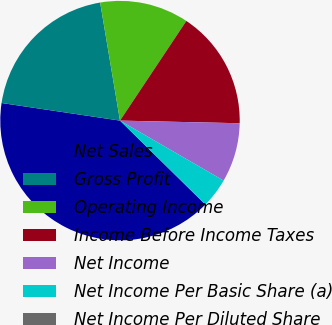Convert chart to OTSL. <chart><loc_0><loc_0><loc_500><loc_500><pie_chart><fcel>Net Sales<fcel>Gross Profit<fcel>Operating Income<fcel>Income Before Income Taxes<fcel>Net Income<fcel>Net Income Per Basic Share (a)<fcel>Net Income Per Diluted Share<nl><fcel>39.98%<fcel>20.0%<fcel>12.0%<fcel>16.0%<fcel>8.0%<fcel>4.01%<fcel>0.01%<nl></chart> 